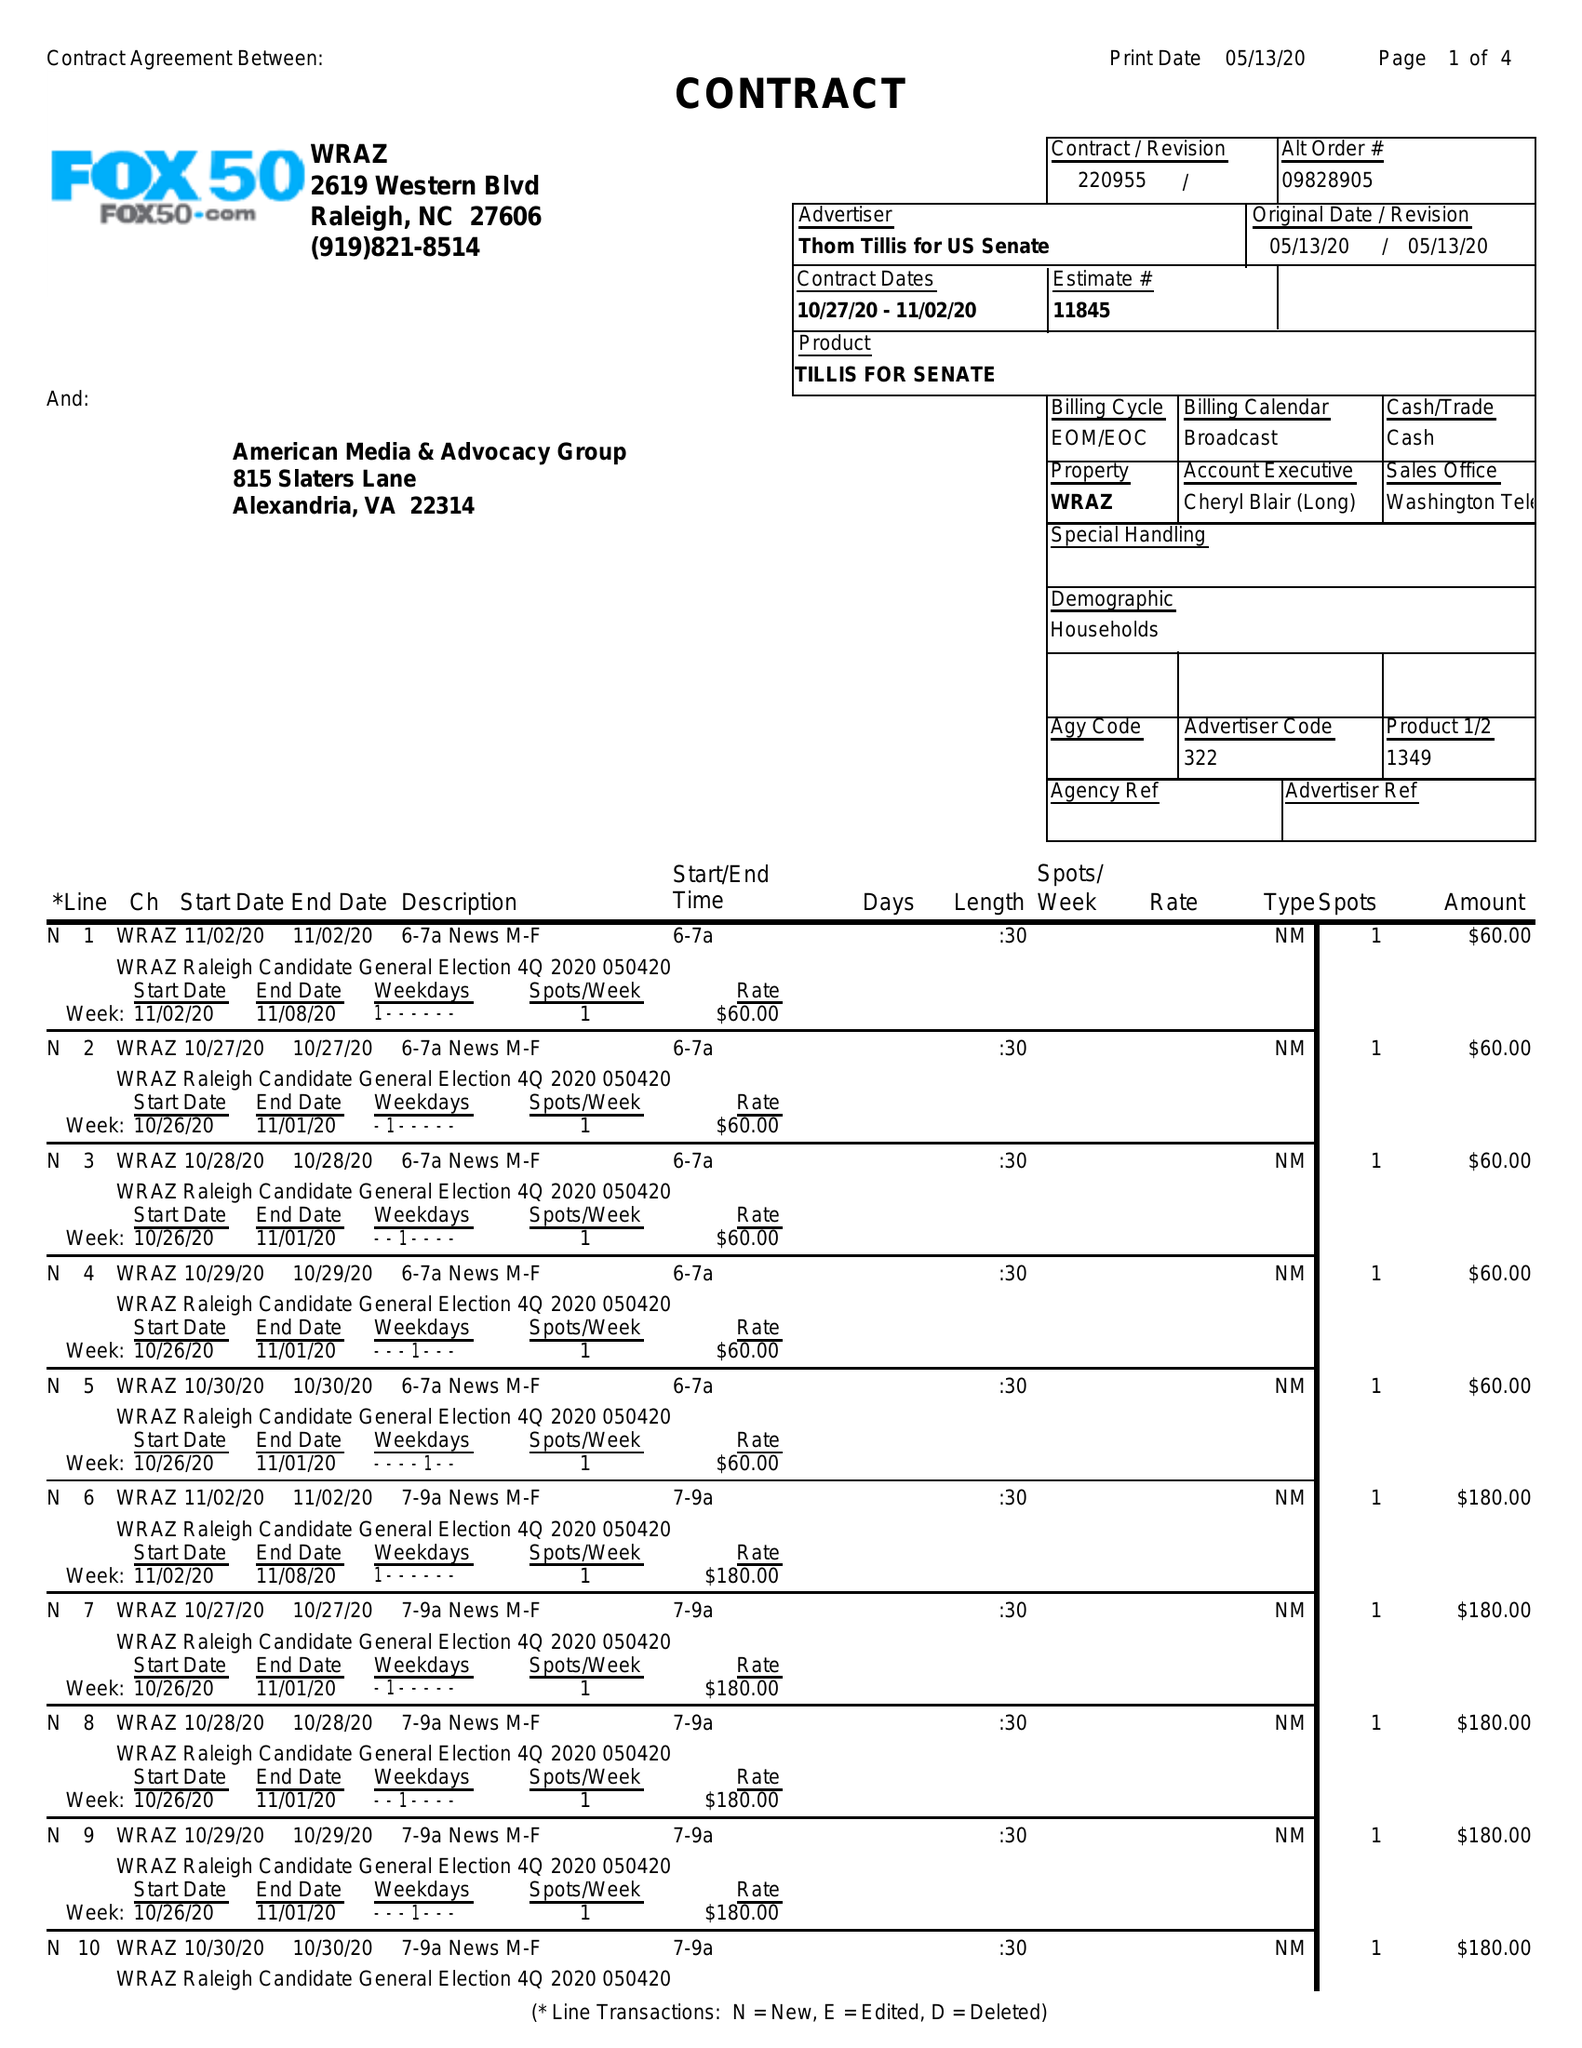What is the value for the advertiser?
Answer the question using a single word or phrase. THOM TILLIS FOR US SENATE 